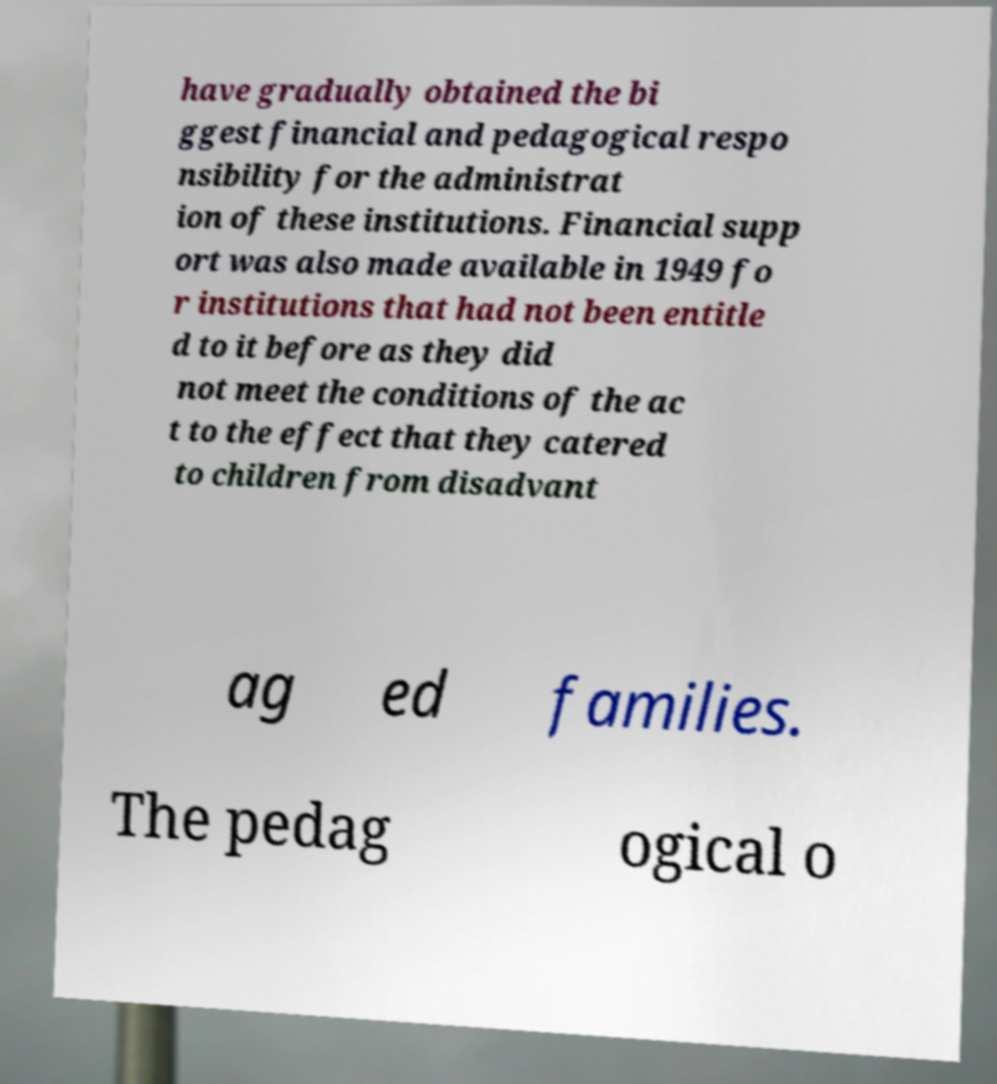Can you accurately transcribe the text from the provided image for me? have gradually obtained the bi ggest financial and pedagogical respo nsibility for the administrat ion of these institutions. Financial supp ort was also made available in 1949 fo r institutions that had not been entitle d to it before as they did not meet the conditions of the ac t to the effect that they catered to children from disadvant ag ed families. The pedag ogical o 